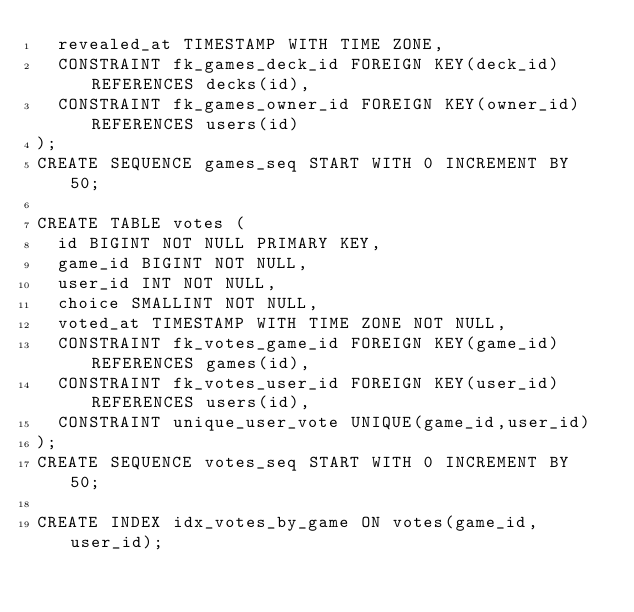Convert code to text. <code><loc_0><loc_0><loc_500><loc_500><_SQL_>  revealed_at TIMESTAMP WITH TIME ZONE,
  CONSTRAINT fk_games_deck_id FOREIGN KEY(deck_id) REFERENCES decks(id),
  CONSTRAINT fk_games_owner_id FOREIGN KEY(owner_id) REFERENCES users(id)
);
CREATE SEQUENCE games_seq START WITH 0 INCREMENT BY 50;

CREATE TABLE votes (
  id BIGINT NOT NULL PRIMARY KEY,
  game_id BIGINT NOT NULL,
  user_id INT NOT NULL,
  choice SMALLINT NOT NULL,
  voted_at TIMESTAMP WITH TIME ZONE NOT NULL,
  CONSTRAINT fk_votes_game_id FOREIGN KEY(game_id) REFERENCES games(id),
  CONSTRAINT fk_votes_user_id FOREIGN KEY(user_id) REFERENCES users(id),
  CONSTRAINT unique_user_vote UNIQUE(game_id,user_id)
);
CREATE SEQUENCE votes_seq START WITH 0 INCREMENT BY 50;

CREATE INDEX idx_votes_by_game ON votes(game_id, user_id);</code> 